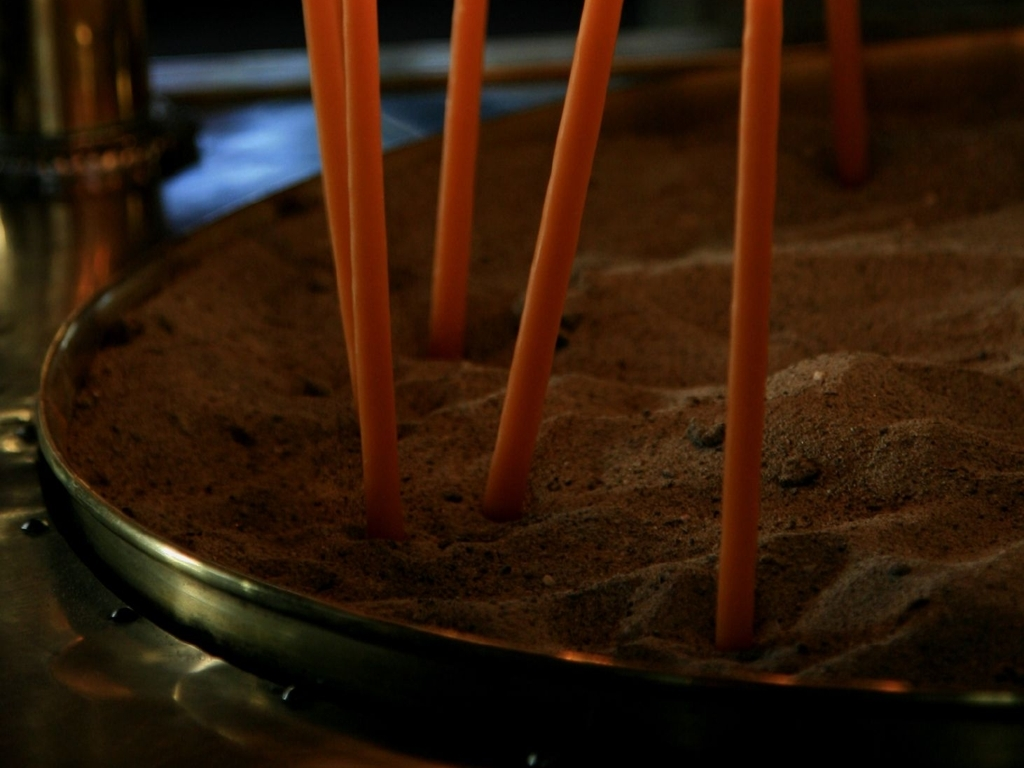What might be the purpose of the candles in the image? The candles, placed firmly in sand within a metal tray, suggest a decorative or ceremonial purpose. They could be part of a relaxation or meditation practice, or they may be used in a spa or as part of a ritual to create an atmosphere of peace and contemplation. 